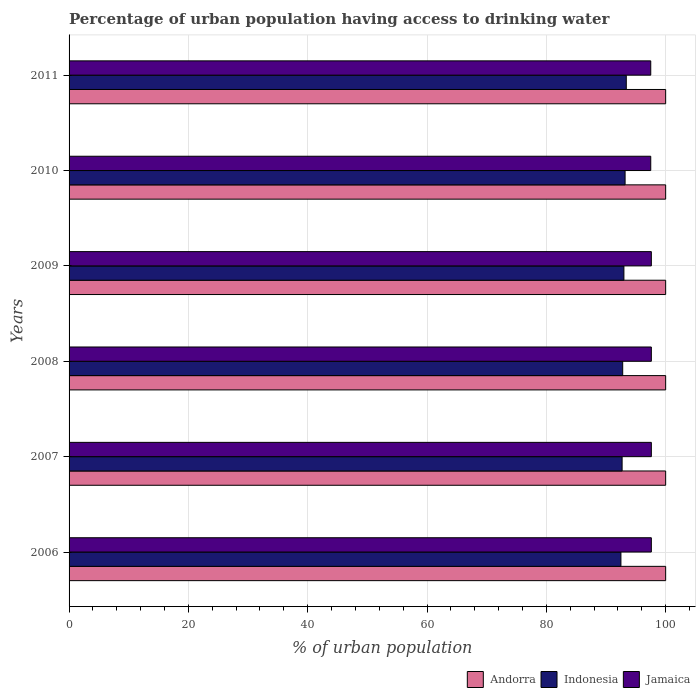How many different coloured bars are there?
Make the answer very short. 3. How many groups of bars are there?
Provide a succinct answer. 6. What is the label of the 3rd group of bars from the top?
Provide a succinct answer. 2009. In how many cases, is the number of bars for a given year not equal to the number of legend labels?
Ensure brevity in your answer.  0. What is the percentage of urban population having access to drinking water in Andorra in 2006?
Offer a terse response. 100. Across all years, what is the maximum percentage of urban population having access to drinking water in Jamaica?
Offer a very short reply. 97.6. Across all years, what is the minimum percentage of urban population having access to drinking water in Jamaica?
Offer a very short reply. 97.5. In which year was the percentage of urban population having access to drinking water in Jamaica maximum?
Your answer should be compact. 2006. What is the total percentage of urban population having access to drinking water in Indonesia in the graph?
Ensure brevity in your answer.  557.6. What is the difference between the percentage of urban population having access to drinking water in Andorra in 2010 and the percentage of urban population having access to drinking water in Jamaica in 2007?
Offer a very short reply. 2.4. What is the average percentage of urban population having access to drinking water in Indonesia per year?
Your response must be concise. 92.93. In the year 2011, what is the difference between the percentage of urban population having access to drinking water in Indonesia and percentage of urban population having access to drinking water in Jamaica?
Offer a terse response. -4.1. What is the ratio of the percentage of urban population having access to drinking water in Indonesia in 2007 to that in 2009?
Make the answer very short. 1. Is the percentage of urban population having access to drinking water in Jamaica in 2007 less than that in 2009?
Your answer should be very brief. No. Is the difference between the percentage of urban population having access to drinking water in Indonesia in 2006 and 2008 greater than the difference between the percentage of urban population having access to drinking water in Jamaica in 2006 and 2008?
Provide a succinct answer. No. What is the difference between the highest and the second highest percentage of urban population having access to drinking water in Andorra?
Give a very brief answer. 0. What is the difference between the highest and the lowest percentage of urban population having access to drinking water in Indonesia?
Make the answer very short. 0.9. In how many years, is the percentage of urban population having access to drinking water in Jamaica greater than the average percentage of urban population having access to drinking water in Jamaica taken over all years?
Provide a short and direct response. 4. Is the sum of the percentage of urban population having access to drinking water in Indonesia in 2006 and 2009 greater than the maximum percentage of urban population having access to drinking water in Andorra across all years?
Keep it short and to the point. Yes. What does the 3rd bar from the top in 2007 represents?
Ensure brevity in your answer.  Andorra. What does the 3rd bar from the bottom in 2010 represents?
Your answer should be very brief. Jamaica. Is it the case that in every year, the sum of the percentage of urban population having access to drinking water in Jamaica and percentage of urban population having access to drinking water in Andorra is greater than the percentage of urban population having access to drinking water in Indonesia?
Your response must be concise. Yes. How many bars are there?
Your answer should be very brief. 18. How many years are there in the graph?
Your response must be concise. 6. What is the difference between two consecutive major ticks on the X-axis?
Offer a very short reply. 20. Does the graph contain any zero values?
Keep it short and to the point. No. Does the graph contain grids?
Your answer should be very brief. Yes. What is the title of the graph?
Your answer should be compact. Percentage of urban population having access to drinking water. Does "Chile" appear as one of the legend labels in the graph?
Your answer should be very brief. No. What is the label or title of the X-axis?
Offer a terse response. % of urban population. What is the label or title of the Y-axis?
Your response must be concise. Years. What is the % of urban population in Andorra in 2006?
Give a very brief answer. 100. What is the % of urban population in Indonesia in 2006?
Give a very brief answer. 92.5. What is the % of urban population of Jamaica in 2006?
Provide a short and direct response. 97.6. What is the % of urban population in Andorra in 2007?
Offer a very short reply. 100. What is the % of urban population in Indonesia in 2007?
Provide a succinct answer. 92.7. What is the % of urban population in Jamaica in 2007?
Your answer should be compact. 97.6. What is the % of urban population of Andorra in 2008?
Provide a short and direct response. 100. What is the % of urban population of Indonesia in 2008?
Keep it short and to the point. 92.8. What is the % of urban population in Jamaica in 2008?
Offer a very short reply. 97.6. What is the % of urban population of Andorra in 2009?
Your response must be concise. 100. What is the % of urban population in Indonesia in 2009?
Ensure brevity in your answer.  93. What is the % of urban population in Jamaica in 2009?
Your answer should be compact. 97.6. What is the % of urban population of Indonesia in 2010?
Give a very brief answer. 93.2. What is the % of urban population in Jamaica in 2010?
Ensure brevity in your answer.  97.5. What is the % of urban population of Andorra in 2011?
Offer a terse response. 100. What is the % of urban population in Indonesia in 2011?
Make the answer very short. 93.4. What is the % of urban population of Jamaica in 2011?
Your answer should be compact. 97.5. Across all years, what is the maximum % of urban population in Andorra?
Give a very brief answer. 100. Across all years, what is the maximum % of urban population in Indonesia?
Your response must be concise. 93.4. Across all years, what is the maximum % of urban population of Jamaica?
Give a very brief answer. 97.6. Across all years, what is the minimum % of urban population of Indonesia?
Provide a short and direct response. 92.5. Across all years, what is the minimum % of urban population in Jamaica?
Provide a succinct answer. 97.5. What is the total % of urban population of Andorra in the graph?
Provide a short and direct response. 600. What is the total % of urban population in Indonesia in the graph?
Provide a succinct answer. 557.6. What is the total % of urban population of Jamaica in the graph?
Provide a succinct answer. 585.4. What is the difference between the % of urban population in Jamaica in 2006 and that in 2007?
Make the answer very short. 0. What is the difference between the % of urban population of Andorra in 2006 and that in 2008?
Your response must be concise. 0. What is the difference between the % of urban population of Indonesia in 2006 and that in 2008?
Ensure brevity in your answer.  -0.3. What is the difference between the % of urban population in Jamaica in 2006 and that in 2008?
Your answer should be very brief. 0. What is the difference between the % of urban population of Indonesia in 2006 and that in 2009?
Provide a succinct answer. -0.5. What is the difference between the % of urban population in Jamaica in 2006 and that in 2009?
Give a very brief answer. 0. What is the difference between the % of urban population in Andorra in 2006 and that in 2010?
Provide a succinct answer. 0. What is the difference between the % of urban population of Andorra in 2006 and that in 2011?
Your answer should be compact. 0. What is the difference between the % of urban population of Jamaica in 2007 and that in 2008?
Give a very brief answer. 0. What is the difference between the % of urban population in Andorra in 2007 and that in 2009?
Keep it short and to the point. 0. What is the difference between the % of urban population in Indonesia in 2007 and that in 2009?
Provide a succinct answer. -0.3. What is the difference between the % of urban population in Jamaica in 2007 and that in 2009?
Your response must be concise. 0. What is the difference between the % of urban population in Indonesia in 2007 and that in 2010?
Your answer should be very brief. -0.5. What is the difference between the % of urban population in Jamaica in 2007 and that in 2010?
Provide a succinct answer. 0.1. What is the difference between the % of urban population in Indonesia in 2008 and that in 2009?
Offer a terse response. -0.2. What is the difference between the % of urban population in Jamaica in 2008 and that in 2010?
Your answer should be very brief. 0.1. What is the difference between the % of urban population in Indonesia in 2009 and that in 2010?
Provide a succinct answer. -0.2. What is the difference between the % of urban population of Andorra in 2009 and that in 2011?
Offer a terse response. 0. What is the difference between the % of urban population of Indonesia in 2009 and that in 2011?
Make the answer very short. -0.4. What is the difference between the % of urban population in Indonesia in 2010 and that in 2011?
Provide a succinct answer. -0.2. What is the difference between the % of urban population in Jamaica in 2010 and that in 2011?
Offer a very short reply. 0. What is the difference between the % of urban population of Andorra in 2006 and the % of urban population of Indonesia in 2007?
Offer a terse response. 7.3. What is the difference between the % of urban population in Indonesia in 2006 and the % of urban population in Jamaica in 2007?
Give a very brief answer. -5.1. What is the difference between the % of urban population of Andorra in 2006 and the % of urban population of Indonesia in 2008?
Your answer should be very brief. 7.2. What is the difference between the % of urban population of Andorra in 2006 and the % of urban population of Jamaica in 2008?
Offer a terse response. 2.4. What is the difference between the % of urban population in Indonesia in 2006 and the % of urban population in Jamaica in 2008?
Offer a terse response. -5.1. What is the difference between the % of urban population in Andorra in 2006 and the % of urban population in Jamaica in 2009?
Your answer should be very brief. 2.4. What is the difference between the % of urban population in Indonesia in 2006 and the % of urban population in Jamaica in 2009?
Provide a succinct answer. -5.1. What is the difference between the % of urban population of Andorra in 2006 and the % of urban population of Jamaica in 2010?
Offer a terse response. 2.5. What is the difference between the % of urban population in Indonesia in 2006 and the % of urban population in Jamaica in 2011?
Make the answer very short. -5. What is the difference between the % of urban population in Andorra in 2007 and the % of urban population in Jamaica in 2008?
Your answer should be very brief. 2.4. What is the difference between the % of urban population in Indonesia in 2007 and the % of urban population in Jamaica in 2009?
Your answer should be compact. -4.9. What is the difference between the % of urban population in Andorra in 2007 and the % of urban population in Indonesia in 2010?
Your response must be concise. 6.8. What is the difference between the % of urban population in Andorra in 2007 and the % of urban population in Indonesia in 2011?
Offer a very short reply. 6.6. What is the difference between the % of urban population in Indonesia in 2007 and the % of urban population in Jamaica in 2011?
Your response must be concise. -4.8. What is the difference between the % of urban population in Andorra in 2008 and the % of urban population in Jamaica in 2009?
Your response must be concise. 2.4. What is the difference between the % of urban population of Andorra in 2008 and the % of urban population of Indonesia in 2010?
Your answer should be compact. 6.8. What is the difference between the % of urban population of Indonesia in 2008 and the % of urban population of Jamaica in 2010?
Give a very brief answer. -4.7. What is the difference between the % of urban population of Andorra in 2008 and the % of urban population of Indonesia in 2011?
Provide a short and direct response. 6.6. What is the difference between the % of urban population of Andorra in 2008 and the % of urban population of Jamaica in 2011?
Provide a short and direct response. 2.5. What is the difference between the % of urban population in Indonesia in 2009 and the % of urban population in Jamaica in 2010?
Offer a terse response. -4.5. What is the difference between the % of urban population in Andorra in 2009 and the % of urban population in Indonesia in 2011?
Give a very brief answer. 6.6. What is the difference between the % of urban population of Andorra in 2009 and the % of urban population of Jamaica in 2011?
Offer a very short reply. 2.5. What is the difference between the % of urban population of Andorra in 2010 and the % of urban population of Jamaica in 2011?
Your answer should be very brief. 2.5. What is the average % of urban population of Indonesia per year?
Your answer should be very brief. 92.93. What is the average % of urban population in Jamaica per year?
Offer a terse response. 97.57. In the year 2006, what is the difference between the % of urban population in Andorra and % of urban population in Indonesia?
Provide a short and direct response. 7.5. In the year 2007, what is the difference between the % of urban population in Andorra and % of urban population in Indonesia?
Your answer should be very brief. 7.3. In the year 2007, what is the difference between the % of urban population in Andorra and % of urban population in Jamaica?
Offer a very short reply. 2.4. In the year 2007, what is the difference between the % of urban population in Indonesia and % of urban population in Jamaica?
Provide a short and direct response. -4.9. In the year 2009, what is the difference between the % of urban population in Andorra and % of urban population in Indonesia?
Give a very brief answer. 7. In the year 2009, what is the difference between the % of urban population in Andorra and % of urban population in Jamaica?
Your answer should be very brief. 2.4. In the year 2009, what is the difference between the % of urban population of Indonesia and % of urban population of Jamaica?
Your answer should be compact. -4.6. In the year 2010, what is the difference between the % of urban population of Andorra and % of urban population of Indonesia?
Ensure brevity in your answer.  6.8. In the year 2010, what is the difference between the % of urban population of Andorra and % of urban population of Jamaica?
Your response must be concise. 2.5. In the year 2010, what is the difference between the % of urban population in Indonesia and % of urban population in Jamaica?
Your answer should be very brief. -4.3. In the year 2011, what is the difference between the % of urban population in Andorra and % of urban population in Indonesia?
Your answer should be very brief. 6.6. In the year 2011, what is the difference between the % of urban population in Indonesia and % of urban population in Jamaica?
Provide a succinct answer. -4.1. What is the ratio of the % of urban population in Indonesia in 2006 to that in 2008?
Your answer should be very brief. 1. What is the ratio of the % of urban population in Jamaica in 2006 to that in 2009?
Provide a succinct answer. 1. What is the ratio of the % of urban population of Andorra in 2006 to that in 2010?
Ensure brevity in your answer.  1. What is the ratio of the % of urban population of Jamaica in 2006 to that in 2010?
Offer a very short reply. 1. What is the ratio of the % of urban population in Jamaica in 2006 to that in 2011?
Offer a terse response. 1. What is the ratio of the % of urban population in Andorra in 2007 to that in 2008?
Provide a succinct answer. 1. What is the ratio of the % of urban population in Indonesia in 2007 to that in 2008?
Offer a very short reply. 1. What is the ratio of the % of urban population in Jamaica in 2007 to that in 2008?
Ensure brevity in your answer.  1. What is the ratio of the % of urban population in Jamaica in 2007 to that in 2009?
Keep it short and to the point. 1. What is the ratio of the % of urban population in Andorra in 2007 to that in 2010?
Your answer should be very brief. 1. What is the ratio of the % of urban population of Indonesia in 2007 to that in 2010?
Make the answer very short. 0.99. What is the ratio of the % of urban population of Andorra in 2007 to that in 2011?
Your answer should be very brief. 1. What is the ratio of the % of urban population of Indonesia in 2007 to that in 2011?
Give a very brief answer. 0.99. What is the ratio of the % of urban population of Indonesia in 2008 to that in 2009?
Provide a short and direct response. 1. What is the ratio of the % of urban population in Andorra in 2008 to that in 2011?
Offer a very short reply. 1. What is the ratio of the % of urban population of Jamaica in 2008 to that in 2011?
Keep it short and to the point. 1. What is the ratio of the % of urban population of Indonesia in 2009 to that in 2010?
Your response must be concise. 1. What is the ratio of the % of urban population in Jamaica in 2009 to that in 2010?
Ensure brevity in your answer.  1. What is the ratio of the % of urban population in Andorra in 2009 to that in 2011?
Provide a short and direct response. 1. What is the ratio of the % of urban population in Indonesia in 2009 to that in 2011?
Ensure brevity in your answer.  1. What is the ratio of the % of urban population in Andorra in 2010 to that in 2011?
Offer a terse response. 1. What is the ratio of the % of urban population of Indonesia in 2010 to that in 2011?
Provide a short and direct response. 1. What is the difference between the highest and the lowest % of urban population of Indonesia?
Ensure brevity in your answer.  0.9. 